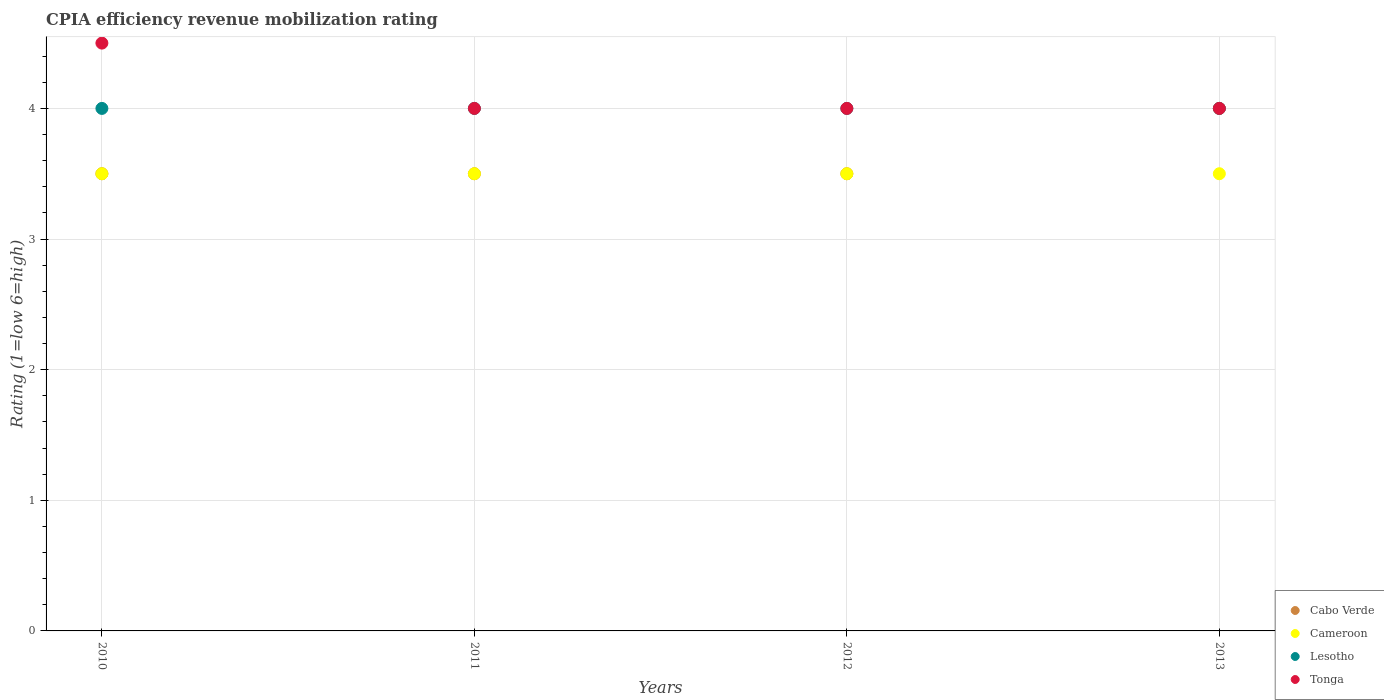How many different coloured dotlines are there?
Your answer should be very brief. 4. Is the number of dotlines equal to the number of legend labels?
Give a very brief answer. Yes. What is the CPIA rating in Cameroon in 2010?
Keep it short and to the point. 3.5. Across all years, what is the maximum CPIA rating in Tonga?
Offer a terse response. 4.5. What is the difference between the CPIA rating in Cabo Verde in 2011 and that in 2013?
Provide a succinct answer. -0.5. What is the average CPIA rating in Tonga per year?
Your answer should be compact. 4.12. In the year 2011, what is the difference between the CPIA rating in Cameroon and CPIA rating in Tonga?
Your answer should be very brief. -0.5. In how many years, is the CPIA rating in Cabo Verde greater than 1.8?
Offer a very short reply. 4. What is the difference between the highest and the second highest CPIA rating in Cabo Verde?
Provide a succinct answer. 0.5. What is the difference between the highest and the lowest CPIA rating in Cameroon?
Your answer should be compact. 0. Is it the case that in every year, the sum of the CPIA rating in Cameroon and CPIA rating in Cabo Verde  is greater than the sum of CPIA rating in Lesotho and CPIA rating in Tonga?
Your response must be concise. No. Is it the case that in every year, the sum of the CPIA rating in Tonga and CPIA rating in Cabo Verde  is greater than the CPIA rating in Lesotho?
Your answer should be very brief. Yes. Is the CPIA rating in Cameroon strictly less than the CPIA rating in Cabo Verde over the years?
Offer a very short reply. No. How many years are there in the graph?
Your response must be concise. 4. Are the values on the major ticks of Y-axis written in scientific E-notation?
Keep it short and to the point. No. How are the legend labels stacked?
Give a very brief answer. Vertical. What is the title of the graph?
Ensure brevity in your answer.  CPIA efficiency revenue mobilization rating. What is the label or title of the Y-axis?
Your answer should be compact. Rating (1=low 6=high). What is the Rating (1=low 6=high) of Cameroon in 2011?
Keep it short and to the point. 3.5. What is the Rating (1=low 6=high) in Lesotho in 2011?
Give a very brief answer. 4. What is the Rating (1=low 6=high) in Cameroon in 2012?
Provide a short and direct response. 3.5. What is the Rating (1=low 6=high) in Tonga in 2012?
Give a very brief answer. 4. Across all years, what is the maximum Rating (1=low 6=high) of Lesotho?
Offer a terse response. 4. Across all years, what is the minimum Rating (1=low 6=high) of Cabo Verde?
Offer a very short reply. 3.5. Across all years, what is the minimum Rating (1=low 6=high) in Cameroon?
Your answer should be very brief. 3.5. Across all years, what is the minimum Rating (1=low 6=high) of Lesotho?
Give a very brief answer. 4. Across all years, what is the minimum Rating (1=low 6=high) of Tonga?
Give a very brief answer. 4. What is the total Rating (1=low 6=high) of Cabo Verde in the graph?
Your answer should be compact. 14.5. What is the difference between the Rating (1=low 6=high) in Cameroon in 2010 and that in 2011?
Ensure brevity in your answer.  0. What is the difference between the Rating (1=low 6=high) in Cabo Verde in 2010 and that in 2012?
Make the answer very short. 0. What is the difference between the Rating (1=low 6=high) in Lesotho in 2010 and that in 2012?
Your answer should be compact. 0. What is the difference between the Rating (1=low 6=high) in Tonga in 2010 and that in 2012?
Ensure brevity in your answer.  0.5. What is the difference between the Rating (1=low 6=high) in Cabo Verde in 2010 and that in 2013?
Provide a succinct answer. -0.5. What is the difference between the Rating (1=low 6=high) of Lesotho in 2010 and that in 2013?
Your response must be concise. 0. What is the difference between the Rating (1=low 6=high) in Cameroon in 2011 and that in 2012?
Ensure brevity in your answer.  0. What is the difference between the Rating (1=low 6=high) of Lesotho in 2011 and that in 2012?
Your answer should be compact. 0. What is the difference between the Rating (1=low 6=high) in Cabo Verde in 2011 and that in 2013?
Offer a terse response. -0.5. What is the difference between the Rating (1=low 6=high) of Cameroon in 2011 and that in 2013?
Your answer should be compact. 0. What is the difference between the Rating (1=low 6=high) of Lesotho in 2012 and that in 2013?
Your response must be concise. 0. What is the difference between the Rating (1=low 6=high) in Tonga in 2012 and that in 2013?
Your response must be concise. 0. What is the difference between the Rating (1=low 6=high) of Cabo Verde in 2010 and the Rating (1=low 6=high) of Lesotho in 2011?
Provide a succinct answer. -0.5. What is the difference between the Rating (1=low 6=high) of Cabo Verde in 2010 and the Rating (1=low 6=high) of Tonga in 2011?
Provide a succinct answer. -0.5. What is the difference between the Rating (1=low 6=high) in Cameroon in 2010 and the Rating (1=low 6=high) in Tonga in 2011?
Your answer should be compact. -0.5. What is the difference between the Rating (1=low 6=high) of Lesotho in 2010 and the Rating (1=low 6=high) of Tonga in 2011?
Keep it short and to the point. 0. What is the difference between the Rating (1=low 6=high) of Cabo Verde in 2010 and the Rating (1=low 6=high) of Cameroon in 2012?
Offer a very short reply. 0. What is the difference between the Rating (1=low 6=high) of Cameroon in 2010 and the Rating (1=low 6=high) of Lesotho in 2012?
Your response must be concise. -0.5. What is the difference between the Rating (1=low 6=high) of Cameroon in 2010 and the Rating (1=low 6=high) of Tonga in 2012?
Offer a very short reply. -0.5. What is the difference between the Rating (1=low 6=high) of Cabo Verde in 2010 and the Rating (1=low 6=high) of Lesotho in 2013?
Provide a succinct answer. -0.5. What is the difference between the Rating (1=low 6=high) in Cabo Verde in 2011 and the Rating (1=low 6=high) in Cameroon in 2012?
Your answer should be very brief. 0. What is the difference between the Rating (1=low 6=high) in Cabo Verde in 2011 and the Rating (1=low 6=high) in Lesotho in 2012?
Ensure brevity in your answer.  -0.5. What is the difference between the Rating (1=low 6=high) of Cameroon in 2011 and the Rating (1=low 6=high) of Lesotho in 2012?
Your answer should be compact. -0.5. What is the difference between the Rating (1=low 6=high) in Cabo Verde in 2011 and the Rating (1=low 6=high) in Cameroon in 2013?
Give a very brief answer. 0. What is the difference between the Rating (1=low 6=high) in Lesotho in 2011 and the Rating (1=low 6=high) in Tonga in 2013?
Your answer should be compact. 0. What is the difference between the Rating (1=low 6=high) of Cameroon in 2012 and the Rating (1=low 6=high) of Lesotho in 2013?
Keep it short and to the point. -0.5. What is the difference between the Rating (1=low 6=high) in Cameroon in 2012 and the Rating (1=low 6=high) in Tonga in 2013?
Your answer should be very brief. -0.5. What is the difference between the Rating (1=low 6=high) in Lesotho in 2012 and the Rating (1=low 6=high) in Tonga in 2013?
Make the answer very short. 0. What is the average Rating (1=low 6=high) in Cabo Verde per year?
Provide a short and direct response. 3.62. What is the average Rating (1=low 6=high) of Cameroon per year?
Make the answer very short. 3.5. What is the average Rating (1=low 6=high) in Lesotho per year?
Provide a short and direct response. 4. What is the average Rating (1=low 6=high) of Tonga per year?
Make the answer very short. 4.12. In the year 2010, what is the difference between the Rating (1=low 6=high) of Cabo Verde and Rating (1=low 6=high) of Cameroon?
Offer a terse response. 0. In the year 2010, what is the difference between the Rating (1=low 6=high) in Cameroon and Rating (1=low 6=high) in Tonga?
Your answer should be very brief. -1. In the year 2010, what is the difference between the Rating (1=low 6=high) in Lesotho and Rating (1=low 6=high) in Tonga?
Ensure brevity in your answer.  -0.5. In the year 2011, what is the difference between the Rating (1=low 6=high) of Cabo Verde and Rating (1=low 6=high) of Cameroon?
Your response must be concise. 0. In the year 2011, what is the difference between the Rating (1=low 6=high) of Cabo Verde and Rating (1=low 6=high) of Lesotho?
Offer a terse response. -0.5. In the year 2011, what is the difference between the Rating (1=low 6=high) in Cameroon and Rating (1=low 6=high) in Lesotho?
Provide a succinct answer. -0.5. In the year 2011, what is the difference between the Rating (1=low 6=high) of Cameroon and Rating (1=low 6=high) of Tonga?
Your answer should be very brief. -0.5. In the year 2011, what is the difference between the Rating (1=low 6=high) of Lesotho and Rating (1=low 6=high) of Tonga?
Your response must be concise. 0. In the year 2012, what is the difference between the Rating (1=low 6=high) of Cabo Verde and Rating (1=low 6=high) of Lesotho?
Your answer should be compact. -0.5. In the year 2012, what is the difference between the Rating (1=low 6=high) in Cabo Verde and Rating (1=low 6=high) in Tonga?
Your answer should be compact. -0.5. In the year 2012, what is the difference between the Rating (1=low 6=high) of Cameroon and Rating (1=low 6=high) of Lesotho?
Offer a terse response. -0.5. In the year 2012, what is the difference between the Rating (1=low 6=high) in Cameroon and Rating (1=low 6=high) in Tonga?
Your response must be concise. -0.5. In the year 2012, what is the difference between the Rating (1=low 6=high) in Lesotho and Rating (1=low 6=high) in Tonga?
Your answer should be compact. 0. In the year 2013, what is the difference between the Rating (1=low 6=high) in Cabo Verde and Rating (1=low 6=high) in Lesotho?
Provide a short and direct response. 0. In the year 2013, what is the difference between the Rating (1=low 6=high) in Cameroon and Rating (1=low 6=high) in Lesotho?
Offer a terse response. -0.5. In the year 2013, what is the difference between the Rating (1=low 6=high) in Cameroon and Rating (1=low 6=high) in Tonga?
Make the answer very short. -0.5. What is the ratio of the Rating (1=low 6=high) of Cabo Verde in 2010 to that in 2011?
Your response must be concise. 1. What is the ratio of the Rating (1=low 6=high) of Tonga in 2010 to that in 2011?
Your response must be concise. 1.12. What is the ratio of the Rating (1=low 6=high) of Cabo Verde in 2010 to that in 2012?
Keep it short and to the point. 1. What is the ratio of the Rating (1=low 6=high) in Cameroon in 2010 to that in 2012?
Provide a short and direct response. 1. What is the ratio of the Rating (1=low 6=high) in Lesotho in 2010 to that in 2012?
Offer a very short reply. 1. What is the ratio of the Rating (1=low 6=high) in Cabo Verde in 2010 to that in 2013?
Give a very brief answer. 0.88. What is the ratio of the Rating (1=low 6=high) in Cameroon in 2010 to that in 2013?
Provide a short and direct response. 1. What is the ratio of the Rating (1=low 6=high) of Cabo Verde in 2011 to that in 2013?
Give a very brief answer. 0.88. What is the ratio of the Rating (1=low 6=high) of Tonga in 2011 to that in 2013?
Your answer should be very brief. 1. What is the ratio of the Rating (1=low 6=high) of Cabo Verde in 2012 to that in 2013?
Your answer should be very brief. 0.88. What is the ratio of the Rating (1=low 6=high) of Lesotho in 2012 to that in 2013?
Provide a short and direct response. 1. What is the difference between the highest and the second highest Rating (1=low 6=high) in Cabo Verde?
Provide a short and direct response. 0.5. What is the difference between the highest and the lowest Rating (1=low 6=high) in Cabo Verde?
Give a very brief answer. 0.5. What is the difference between the highest and the lowest Rating (1=low 6=high) of Cameroon?
Ensure brevity in your answer.  0. What is the difference between the highest and the lowest Rating (1=low 6=high) of Tonga?
Your answer should be very brief. 0.5. 